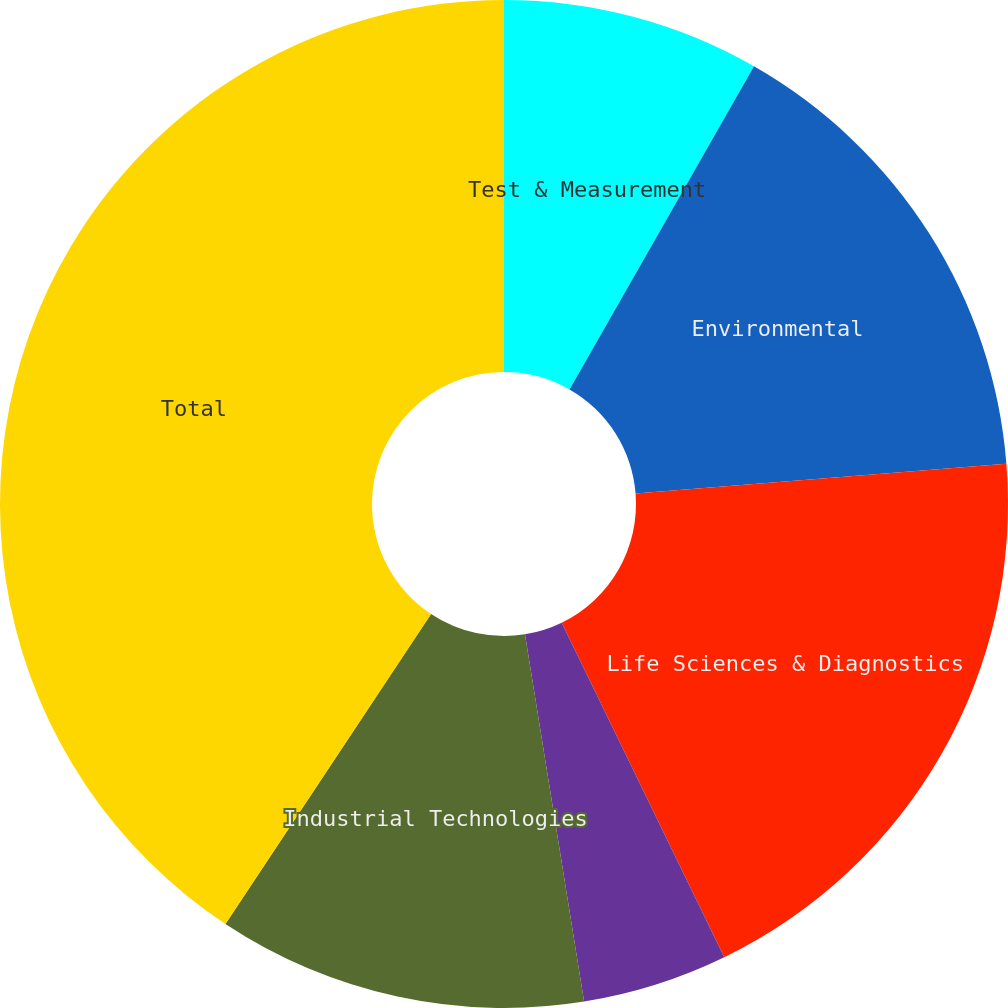<chart> <loc_0><loc_0><loc_500><loc_500><pie_chart><fcel>Test & Measurement<fcel>Environmental<fcel>Life Sciences & Diagnostics<fcel>Dental<fcel>Industrial Technologies<fcel>Total<nl><fcel>8.26%<fcel>15.47%<fcel>19.07%<fcel>4.66%<fcel>11.86%<fcel>40.68%<nl></chart> 